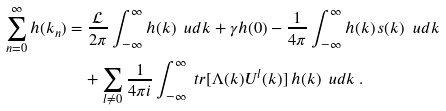<formula> <loc_0><loc_0><loc_500><loc_500>\sum _ { n = 0 } ^ { \infty } h ( k _ { n } ) & = \frac { \mathcal { L } } { 2 \pi } \int _ { - \infty } ^ { \infty } h ( k ) \ \ u d k + \gamma h ( 0 ) - \frac { 1 } { 4 \pi } \int _ { - \infty } ^ { \infty } h ( k ) \, s ( k ) \ \ u d k \\ & \quad + \sum _ { l \neq 0 } \frac { 1 } { 4 \pi i } \int _ { - \infty } ^ { \infty } \ t r [ \Lambda ( k ) U ^ { l } ( k ) ] \, h ( k ) \ \ u d k \ .</formula> 